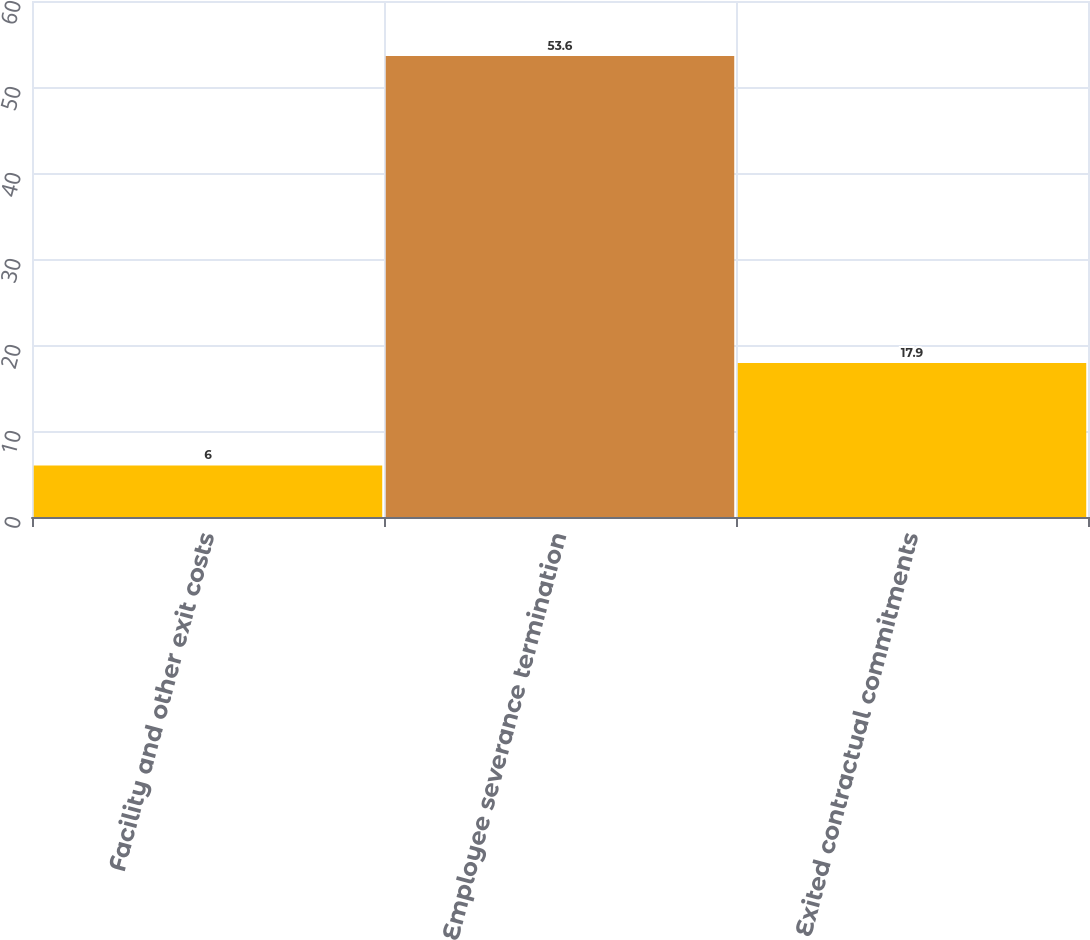Convert chart to OTSL. <chart><loc_0><loc_0><loc_500><loc_500><bar_chart><fcel>Facility and other exit costs<fcel>Employee severance termination<fcel>Exited contractual commitments<nl><fcel>6<fcel>53.6<fcel>17.9<nl></chart> 